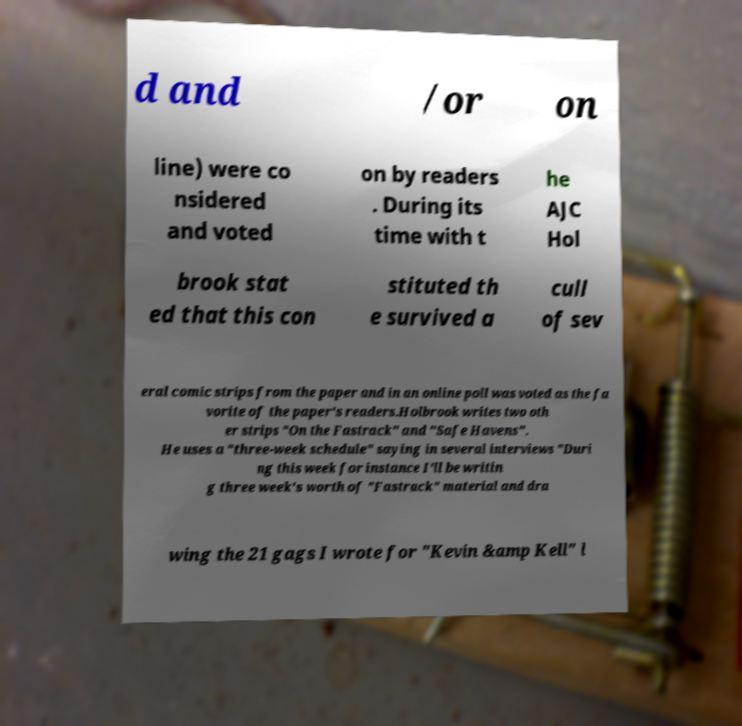Could you assist in decoding the text presented in this image and type it out clearly? d and /or on line) were co nsidered and voted on by readers . During its time with t he AJC Hol brook stat ed that this con stituted th e survived a cull of sev eral comic strips from the paper and in an online poll was voted as the fa vorite of the paper's readers.Holbrook writes two oth er strips "On the Fastrack" and "Safe Havens". He uses a "three-week schedule" saying in several interviews "Duri ng this week for instance I'll be writin g three week's worth of "Fastrack" material and dra wing the 21 gags I wrote for "Kevin &amp Kell" l 